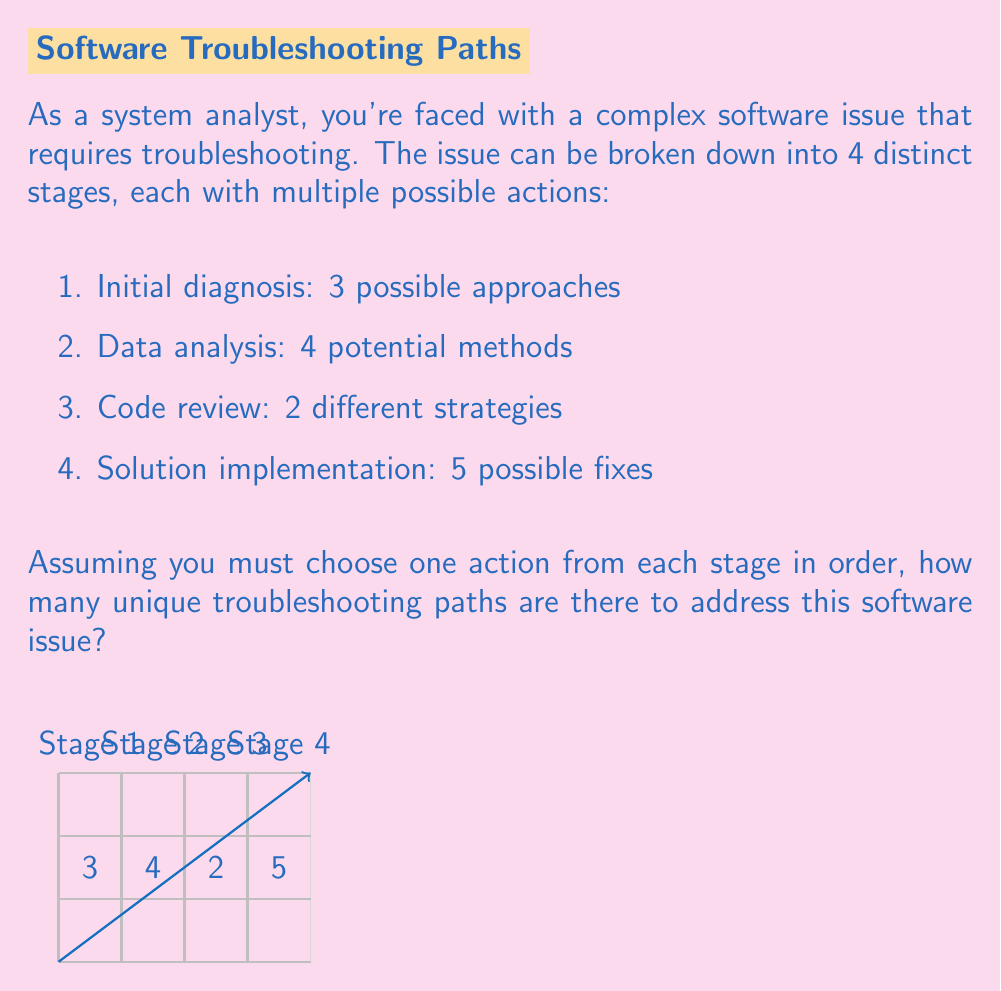Can you solve this math problem? To solve this problem, we'll use the multiplicative principle of counting. This principle states that if we have a sequence of choices, and the number of options for each choice is independent of the other choices, then the total number of possible outcomes is the product of the number of options for each choice.

Let's break it down step by step:

1. Initial diagnosis: 3 possible approaches
2. Data analysis: 4 potential methods
3. Code review: 2 different strategies
4. Solution implementation: 5 possible fixes

For each complete troubleshooting path, we need to make one choice from each stage. The number of ways to do this is:

$$ 3 \times 4 \times 2 \times 5 $$

This is because:
- We have 3 choices for the first stage
- For each of those choices, we have 4 choices for the second stage
- For each combination of the first two stages, we have 2 choices for the third stage
- And finally, for each combination of the first three stages, we have 5 choices for the last stage

Therefore, the total number of unique troubleshooting paths is:

$$ 3 \times 4 \times 2 \times 5 = 120 $$

This calculation gives us the total number of ways to create a complete troubleshooting path by selecting one option from each stage.
Answer: 120 unique paths 